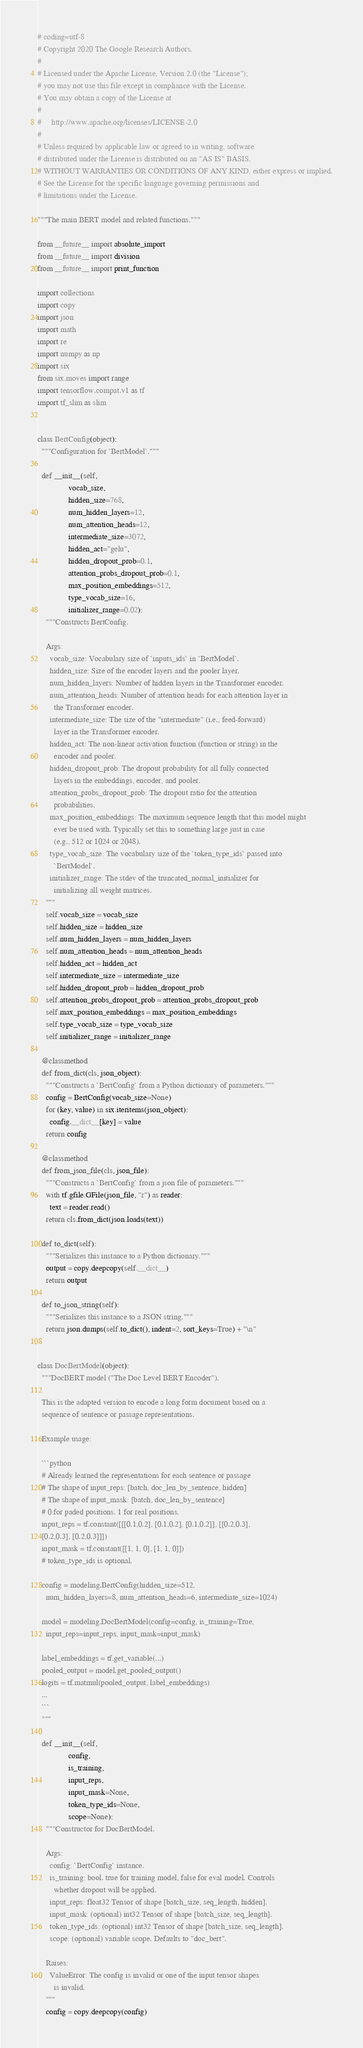<code> <loc_0><loc_0><loc_500><loc_500><_Python_># coding=utf-8
# Copyright 2020 The Google Research Authors.
#
# Licensed under the Apache License, Version 2.0 (the "License");
# you may not use this file except in compliance with the License.
# You may obtain a copy of the License at
#
#     http://www.apache.org/licenses/LICENSE-2.0
#
# Unless required by applicable law or agreed to in writing, software
# distributed under the License is distributed on an "AS IS" BASIS,
# WITHOUT WARRANTIES OR CONDITIONS OF ANY KIND, either express or implied.
# See the License for the specific language governing permissions and
# limitations under the License.

"""The main BERT model and related functions."""

from __future__ import absolute_import
from __future__ import division
from __future__ import print_function

import collections
import copy
import json
import math
import re
import numpy as np
import six
from six.moves import range
import tensorflow.compat.v1 as tf
import tf_slim as slim


class BertConfig(object):
  """Configuration for `BertModel`."""

  def __init__(self,
               vocab_size,
               hidden_size=768,
               num_hidden_layers=12,
               num_attention_heads=12,
               intermediate_size=3072,
               hidden_act="gelu",
               hidden_dropout_prob=0.1,
               attention_probs_dropout_prob=0.1,
               max_position_embeddings=512,
               type_vocab_size=16,
               initializer_range=0.02):
    """Constructs BertConfig.

    Args:
      vocab_size: Vocabulary size of `inputs_ids` in `BertModel`.
      hidden_size: Size of the encoder layers and the pooler layer.
      num_hidden_layers: Number of hidden layers in the Transformer encoder.
      num_attention_heads: Number of attention heads for each attention layer in
        the Transformer encoder.
      intermediate_size: The size of the "intermediate" (i.e., feed-forward)
        layer in the Transformer encoder.
      hidden_act: The non-linear activation function (function or string) in the
        encoder and pooler.
      hidden_dropout_prob: The dropout probability for all fully connected
        layers in the embeddings, encoder, and pooler.
      attention_probs_dropout_prob: The dropout ratio for the attention
        probabilities.
      max_position_embeddings: The maximum sequence length that this model might
        ever be used with. Typically set this to something large just in case
        (e.g., 512 or 1024 or 2048).
      type_vocab_size: The vocabulary size of the `token_type_ids` passed into
        `BertModel`.
      initializer_range: The stdev of the truncated_normal_initializer for
        initializing all weight matrices.
    """
    self.vocab_size = vocab_size
    self.hidden_size = hidden_size
    self.num_hidden_layers = num_hidden_layers
    self.num_attention_heads = num_attention_heads
    self.hidden_act = hidden_act
    self.intermediate_size = intermediate_size
    self.hidden_dropout_prob = hidden_dropout_prob
    self.attention_probs_dropout_prob = attention_probs_dropout_prob
    self.max_position_embeddings = max_position_embeddings
    self.type_vocab_size = type_vocab_size
    self.initializer_range = initializer_range

  @classmethod
  def from_dict(cls, json_object):
    """Constructs a `BertConfig` from a Python dictionary of parameters."""
    config = BertConfig(vocab_size=None)
    for (key, value) in six.iteritems(json_object):
      config.__dict__[key] = value
    return config

  @classmethod
  def from_json_file(cls, json_file):
    """Constructs a `BertConfig` from a json file of parameters."""
    with tf.gfile.GFile(json_file, "r") as reader:
      text = reader.read()
    return cls.from_dict(json.loads(text))

  def to_dict(self):
    """Serializes this instance to a Python dictionary."""
    output = copy.deepcopy(self.__dict__)
    return output

  def to_json_string(self):
    """Serializes this instance to a JSON string."""
    return json.dumps(self.to_dict(), indent=2, sort_keys=True) + "\n"


class DocBertModel(object):
  """DocBERT model ("The Doc Level BERT Encoder").

  This is the adapted version to encode a long form document based on a
  sequence of sentence or passage representations.

  Example usage:

  ```python
  # Already learned the representations for each sentence or passage
  # The shape of input_reps: [batch, doc_len_by_sentence, hidden]
  # The shape of input_mask: [batch, doc_len_by_sentence]
  # 0 for paded positions. 1 for real positions.
  input_reps = tf.constant([[[0.1,0.2], [0.1,0.2], [0.1,0.2]], [[0.2,0.3],
  [0.2,0.3], [0.2,0.3]]])
  input_mask = tf.constant([[1, 1, 0], [1, 1, 0]])
  # token_type_ids is optional.

  config = modeling.BertConfig(hidden_size=512,
    num_hidden_layers=8, num_attention_heads=6, intermediate_size=1024)

  model = modeling.DocBertModel(config=config, is_training=True,
    input_reps=input_reps, input_mask=input_mask)

  label_embeddings = tf.get_variable(...)
  pooled_output = model.get_pooled_output()
  logits = tf.matmul(pooled_output, label_embeddings)
  ...
  ```
  """

  def __init__(self,
               config,
               is_training,
               input_reps,
               input_mask=None,
               token_type_ids=None,
               scope=None):
    """Constructor for DocBertModel.

    Args:
      config: `BertConfig` instance.
      is_training: bool. true for training model, false for eval model. Controls
        whether dropout will be applied.
      input_reps: float32 Tensor of shape [batch_size, seq_length, hidden].
      input_mask: (optional) int32 Tensor of shape [batch_size, seq_length].
      token_type_ids: (optional) int32 Tensor of shape [batch_size, seq_length].
      scope: (optional) variable scope. Defaults to "doc_bert".

    Raises:
      ValueError: The config is invalid or one of the input tensor shapes
        is invalid.
    """
    config = copy.deepcopy(config)</code> 